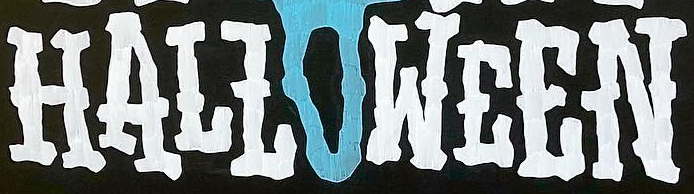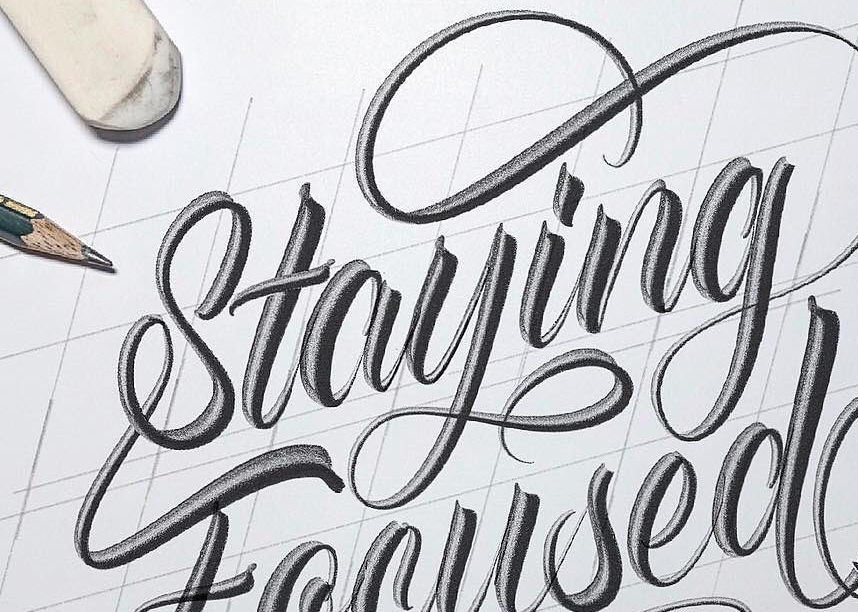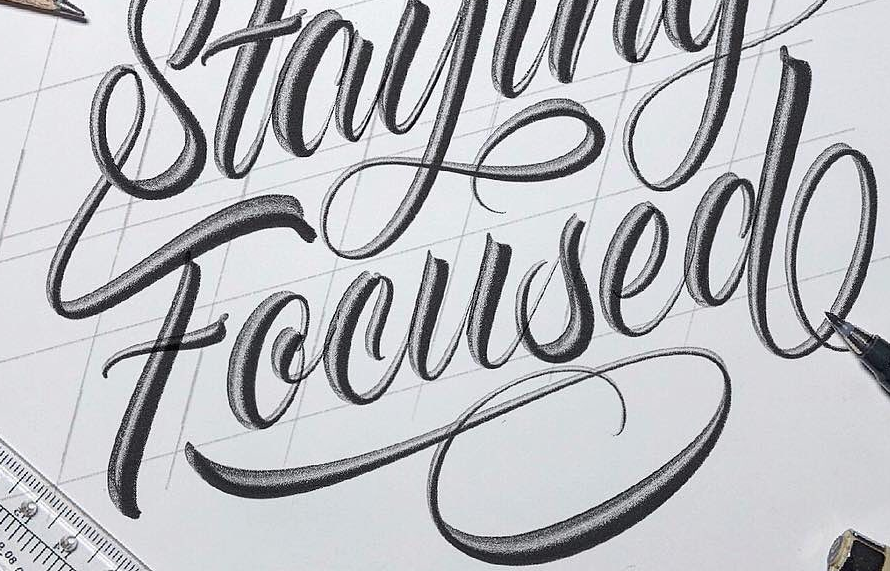Identify the words shown in these images in order, separated by a semicolon. HALLOWEEN; Staying; Focused 